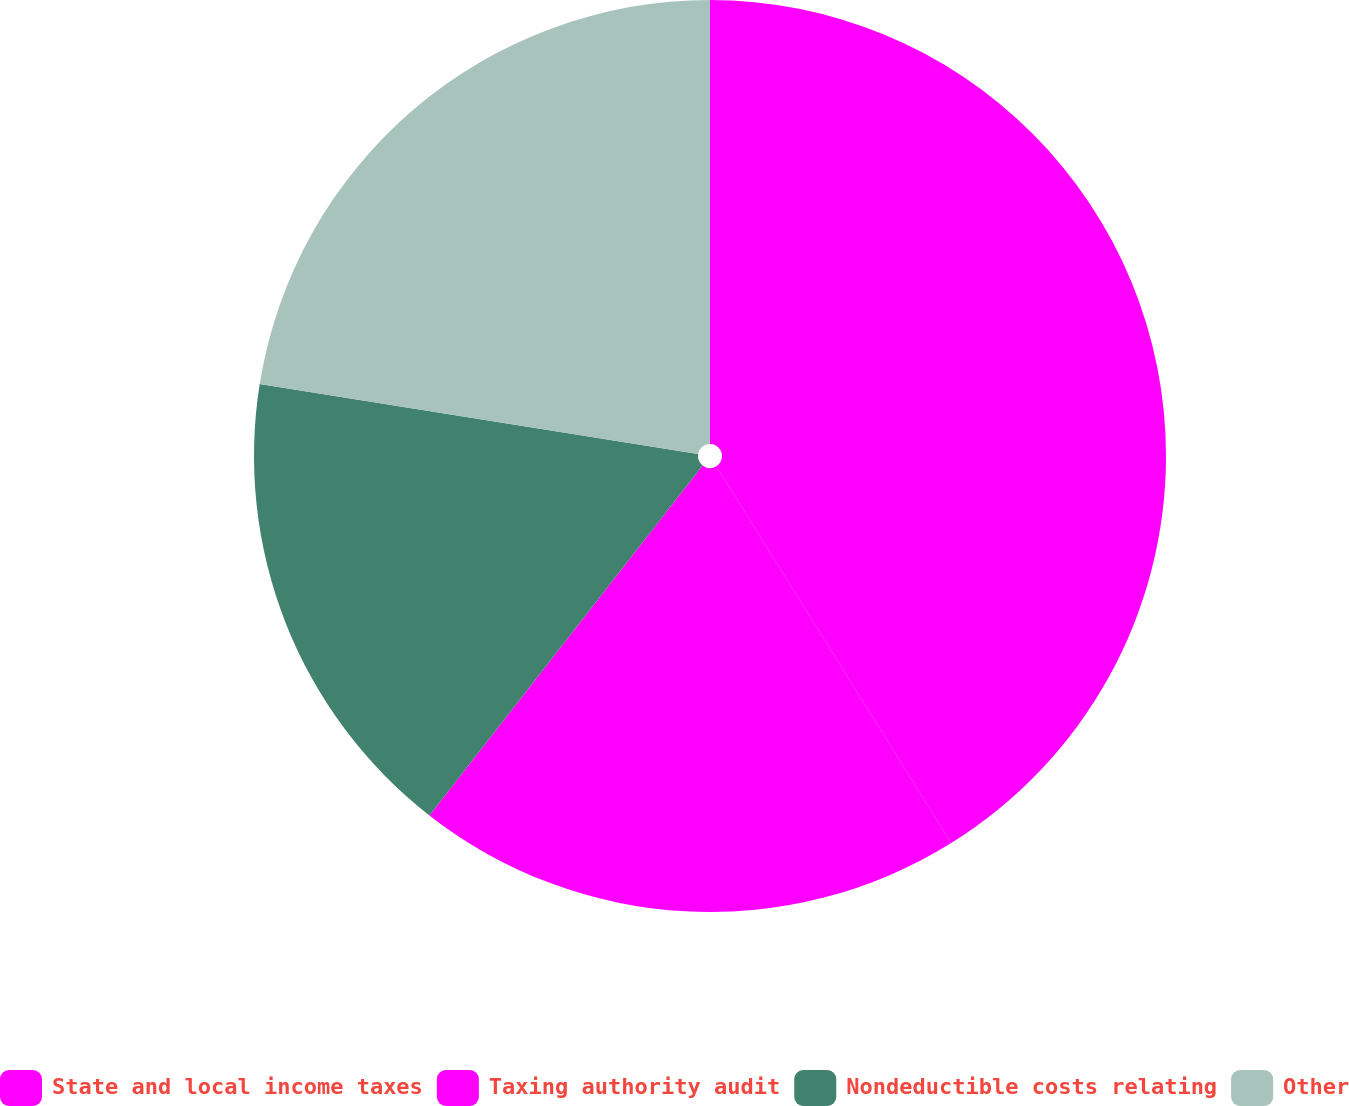Convert chart to OTSL. <chart><loc_0><loc_0><loc_500><loc_500><pie_chart><fcel>State and local income taxes<fcel>Taxing authority audit<fcel>Nondeductible costs relating<fcel>Other<nl><fcel>41.13%<fcel>19.42%<fcel>16.97%<fcel>22.48%<nl></chart> 